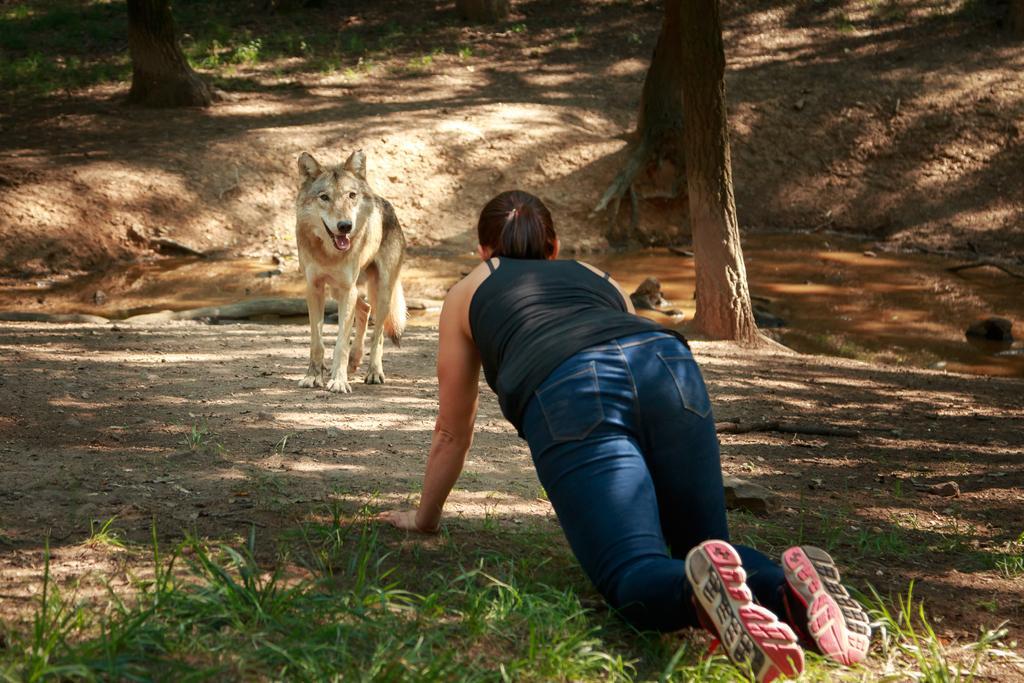How would you summarize this image in a sentence or two? In this image we can see a dog and a woman on the ground. We can also see some grass, water and the bark of the trees. 